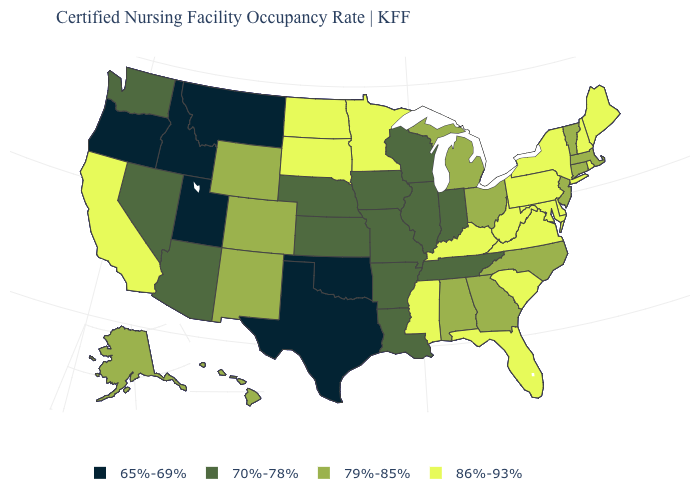What is the value of Pennsylvania?
Give a very brief answer. 86%-93%. Name the states that have a value in the range 70%-78%?
Concise answer only. Arizona, Arkansas, Illinois, Indiana, Iowa, Kansas, Louisiana, Missouri, Nebraska, Nevada, Tennessee, Washington, Wisconsin. Does Ohio have a higher value than Utah?
Answer briefly. Yes. What is the highest value in the MidWest ?
Concise answer only. 86%-93%. What is the highest value in the West ?
Be succinct. 86%-93%. Among the states that border Utah , does Wyoming have the highest value?
Short answer required. Yes. Name the states that have a value in the range 79%-85%?
Concise answer only. Alabama, Alaska, Colorado, Connecticut, Georgia, Hawaii, Massachusetts, Michigan, New Jersey, New Mexico, North Carolina, Ohio, Vermont, Wyoming. Name the states that have a value in the range 65%-69%?
Keep it brief. Idaho, Montana, Oklahoma, Oregon, Texas, Utah. Name the states that have a value in the range 70%-78%?
Quick response, please. Arizona, Arkansas, Illinois, Indiana, Iowa, Kansas, Louisiana, Missouri, Nebraska, Nevada, Tennessee, Washington, Wisconsin. What is the value of Colorado?
Give a very brief answer. 79%-85%. Does Arizona have a lower value than North Dakota?
Answer briefly. Yes. What is the lowest value in states that border New York?
Concise answer only. 79%-85%. What is the value of Wisconsin?
Answer briefly. 70%-78%. Is the legend a continuous bar?
Write a very short answer. No. 